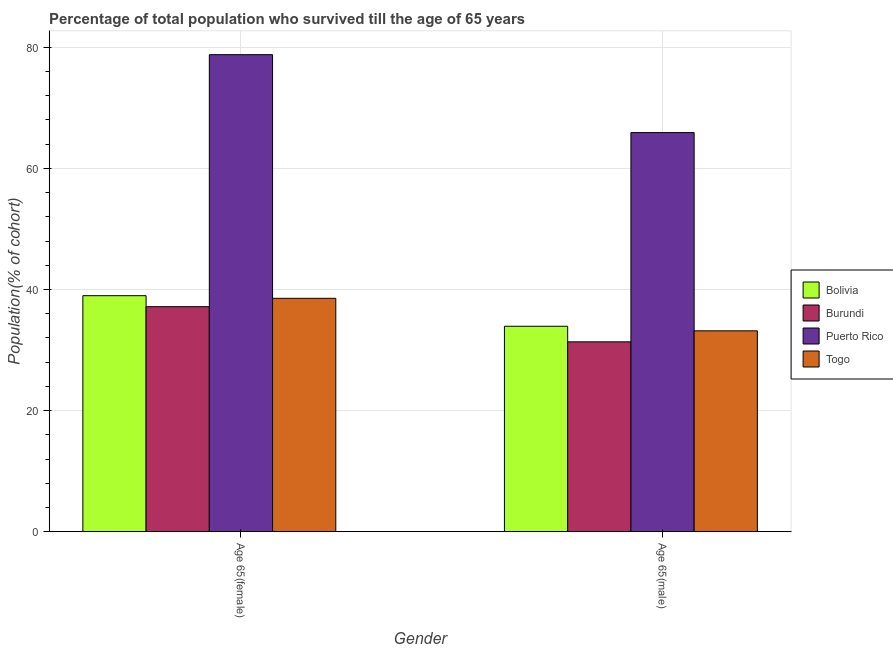Are the number of bars per tick equal to the number of legend labels?
Give a very brief answer. Yes. How many bars are there on the 1st tick from the left?
Ensure brevity in your answer.  4. How many bars are there on the 1st tick from the right?
Ensure brevity in your answer.  4. What is the label of the 2nd group of bars from the left?
Provide a succinct answer. Age 65(male). What is the percentage of male population who survived till age of 65 in Bolivia?
Your answer should be very brief. 33.93. Across all countries, what is the maximum percentage of male population who survived till age of 65?
Provide a short and direct response. 65.91. Across all countries, what is the minimum percentage of female population who survived till age of 65?
Give a very brief answer. 37.16. In which country was the percentage of male population who survived till age of 65 maximum?
Offer a very short reply. Puerto Rico. In which country was the percentage of female population who survived till age of 65 minimum?
Keep it short and to the point. Burundi. What is the total percentage of male population who survived till age of 65 in the graph?
Give a very brief answer. 164.38. What is the difference between the percentage of female population who survived till age of 65 in Burundi and that in Togo?
Provide a succinct answer. -1.38. What is the difference between the percentage of female population who survived till age of 65 in Puerto Rico and the percentage of male population who survived till age of 65 in Bolivia?
Keep it short and to the point. 44.85. What is the average percentage of female population who survived till age of 65 per country?
Ensure brevity in your answer.  48.37. What is the difference between the percentage of female population who survived till age of 65 and percentage of male population who survived till age of 65 in Togo?
Your answer should be very brief. 5.37. What is the ratio of the percentage of female population who survived till age of 65 in Togo to that in Burundi?
Give a very brief answer. 1.04. Is the percentage of male population who survived till age of 65 in Togo less than that in Bolivia?
Make the answer very short. Yes. What does the 2nd bar from the right in Age 65(male) represents?
Offer a very short reply. Puerto Rico. How many bars are there?
Your answer should be very brief. 8. What is the difference between two consecutive major ticks on the Y-axis?
Give a very brief answer. 20. Does the graph contain any zero values?
Ensure brevity in your answer.  No. Does the graph contain grids?
Offer a very short reply. Yes. How many legend labels are there?
Provide a short and direct response. 4. How are the legend labels stacked?
Make the answer very short. Vertical. What is the title of the graph?
Provide a succinct answer. Percentage of total population who survived till the age of 65 years. What is the label or title of the X-axis?
Your answer should be compact. Gender. What is the label or title of the Y-axis?
Your answer should be very brief. Population(% of cohort). What is the Population(% of cohort) of Bolivia in Age 65(female)?
Give a very brief answer. 38.98. What is the Population(% of cohort) in Burundi in Age 65(female)?
Keep it short and to the point. 37.16. What is the Population(% of cohort) of Puerto Rico in Age 65(female)?
Your answer should be very brief. 78.78. What is the Population(% of cohort) of Togo in Age 65(female)?
Your answer should be very brief. 38.54. What is the Population(% of cohort) in Bolivia in Age 65(male)?
Keep it short and to the point. 33.93. What is the Population(% of cohort) in Burundi in Age 65(male)?
Keep it short and to the point. 31.36. What is the Population(% of cohort) in Puerto Rico in Age 65(male)?
Offer a terse response. 65.91. What is the Population(% of cohort) of Togo in Age 65(male)?
Your response must be concise. 33.18. Across all Gender, what is the maximum Population(% of cohort) of Bolivia?
Offer a terse response. 38.98. Across all Gender, what is the maximum Population(% of cohort) of Burundi?
Your answer should be very brief. 37.16. Across all Gender, what is the maximum Population(% of cohort) of Puerto Rico?
Ensure brevity in your answer.  78.78. Across all Gender, what is the maximum Population(% of cohort) of Togo?
Give a very brief answer. 38.54. Across all Gender, what is the minimum Population(% of cohort) in Bolivia?
Offer a terse response. 33.93. Across all Gender, what is the minimum Population(% of cohort) of Burundi?
Provide a succinct answer. 31.36. Across all Gender, what is the minimum Population(% of cohort) of Puerto Rico?
Your answer should be compact. 65.91. Across all Gender, what is the minimum Population(% of cohort) in Togo?
Give a very brief answer. 33.18. What is the total Population(% of cohort) in Bolivia in the graph?
Offer a very short reply. 72.91. What is the total Population(% of cohort) of Burundi in the graph?
Make the answer very short. 68.52. What is the total Population(% of cohort) of Puerto Rico in the graph?
Offer a very short reply. 144.69. What is the total Population(% of cohort) of Togo in the graph?
Your answer should be compact. 71.72. What is the difference between the Population(% of cohort) of Bolivia in Age 65(female) and that in Age 65(male)?
Make the answer very short. 5.05. What is the difference between the Population(% of cohort) of Burundi in Age 65(female) and that in Age 65(male)?
Ensure brevity in your answer.  5.81. What is the difference between the Population(% of cohort) in Puerto Rico in Age 65(female) and that in Age 65(male)?
Provide a succinct answer. 12.87. What is the difference between the Population(% of cohort) of Togo in Age 65(female) and that in Age 65(male)?
Make the answer very short. 5.37. What is the difference between the Population(% of cohort) of Bolivia in Age 65(female) and the Population(% of cohort) of Burundi in Age 65(male)?
Your answer should be very brief. 7.62. What is the difference between the Population(% of cohort) of Bolivia in Age 65(female) and the Population(% of cohort) of Puerto Rico in Age 65(male)?
Provide a succinct answer. -26.93. What is the difference between the Population(% of cohort) of Bolivia in Age 65(female) and the Population(% of cohort) of Togo in Age 65(male)?
Keep it short and to the point. 5.8. What is the difference between the Population(% of cohort) of Burundi in Age 65(female) and the Population(% of cohort) of Puerto Rico in Age 65(male)?
Give a very brief answer. -28.75. What is the difference between the Population(% of cohort) in Burundi in Age 65(female) and the Population(% of cohort) in Togo in Age 65(male)?
Offer a very short reply. 3.99. What is the difference between the Population(% of cohort) of Puerto Rico in Age 65(female) and the Population(% of cohort) of Togo in Age 65(male)?
Provide a succinct answer. 45.6. What is the average Population(% of cohort) in Bolivia per Gender?
Ensure brevity in your answer.  36.45. What is the average Population(% of cohort) of Burundi per Gender?
Ensure brevity in your answer.  34.26. What is the average Population(% of cohort) of Puerto Rico per Gender?
Your response must be concise. 72.35. What is the average Population(% of cohort) of Togo per Gender?
Offer a terse response. 35.86. What is the difference between the Population(% of cohort) in Bolivia and Population(% of cohort) in Burundi in Age 65(female)?
Provide a succinct answer. 1.82. What is the difference between the Population(% of cohort) of Bolivia and Population(% of cohort) of Puerto Rico in Age 65(female)?
Your response must be concise. -39.8. What is the difference between the Population(% of cohort) in Bolivia and Population(% of cohort) in Togo in Age 65(female)?
Offer a terse response. 0.44. What is the difference between the Population(% of cohort) in Burundi and Population(% of cohort) in Puerto Rico in Age 65(female)?
Keep it short and to the point. -41.62. What is the difference between the Population(% of cohort) of Burundi and Population(% of cohort) of Togo in Age 65(female)?
Offer a terse response. -1.38. What is the difference between the Population(% of cohort) of Puerto Rico and Population(% of cohort) of Togo in Age 65(female)?
Ensure brevity in your answer.  40.24. What is the difference between the Population(% of cohort) in Bolivia and Population(% of cohort) in Burundi in Age 65(male)?
Offer a very short reply. 2.57. What is the difference between the Population(% of cohort) of Bolivia and Population(% of cohort) of Puerto Rico in Age 65(male)?
Your answer should be compact. -31.98. What is the difference between the Population(% of cohort) of Bolivia and Population(% of cohort) of Togo in Age 65(male)?
Your response must be concise. 0.75. What is the difference between the Population(% of cohort) of Burundi and Population(% of cohort) of Puerto Rico in Age 65(male)?
Provide a succinct answer. -34.56. What is the difference between the Population(% of cohort) in Burundi and Population(% of cohort) in Togo in Age 65(male)?
Your answer should be compact. -1.82. What is the difference between the Population(% of cohort) in Puerto Rico and Population(% of cohort) in Togo in Age 65(male)?
Provide a succinct answer. 32.74. What is the ratio of the Population(% of cohort) in Bolivia in Age 65(female) to that in Age 65(male)?
Offer a very short reply. 1.15. What is the ratio of the Population(% of cohort) of Burundi in Age 65(female) to that in Age 65(male)?
Offer a very short reply. 1.19. What is the ratio of the Population(% of cohort) of Puerto Rico in Age 65(female) to that in Age 65(male)?
Make the answer very short. 1.2. What is the ratio of the Population(% of cohort) of Togo in Age 65(female) to that in Age 65(male)?
Offer a terse response. 1.16. What is the difference between the highest and the second highest Population(% of cohort) of Bolivia?
Keep it short and to the point. 5.05. What is the difference between the highest and the second highest Population(% of cohort) of Burundi?
Ensure brevity in your answer.  5.81. What is the difference between the highest and the second highest Population(% of cohort) of Puerto Rico?
Offer a very short reply. 12.87. What is the difference between the highest and the second highest Population(% of cohort) in Togo?
Provide a short and direct response. 5.37. What is the difference between the highest and the lowest Population(% of cohort) in Bolivia?
Offer a terse response. 5.05. What is the difference between the highest and the lowest Population(% of cohort) in Burundi?
Provide a succinct answer. 5.81. What is the difference between the highest and the lowest Population(% of cohort) in Puerto Rico?
Offer a terse response. 12.87. What is the difference between the highest and the lowest Population(% of cohort) of Togo?
Provide a short and direct response. 5.37. 